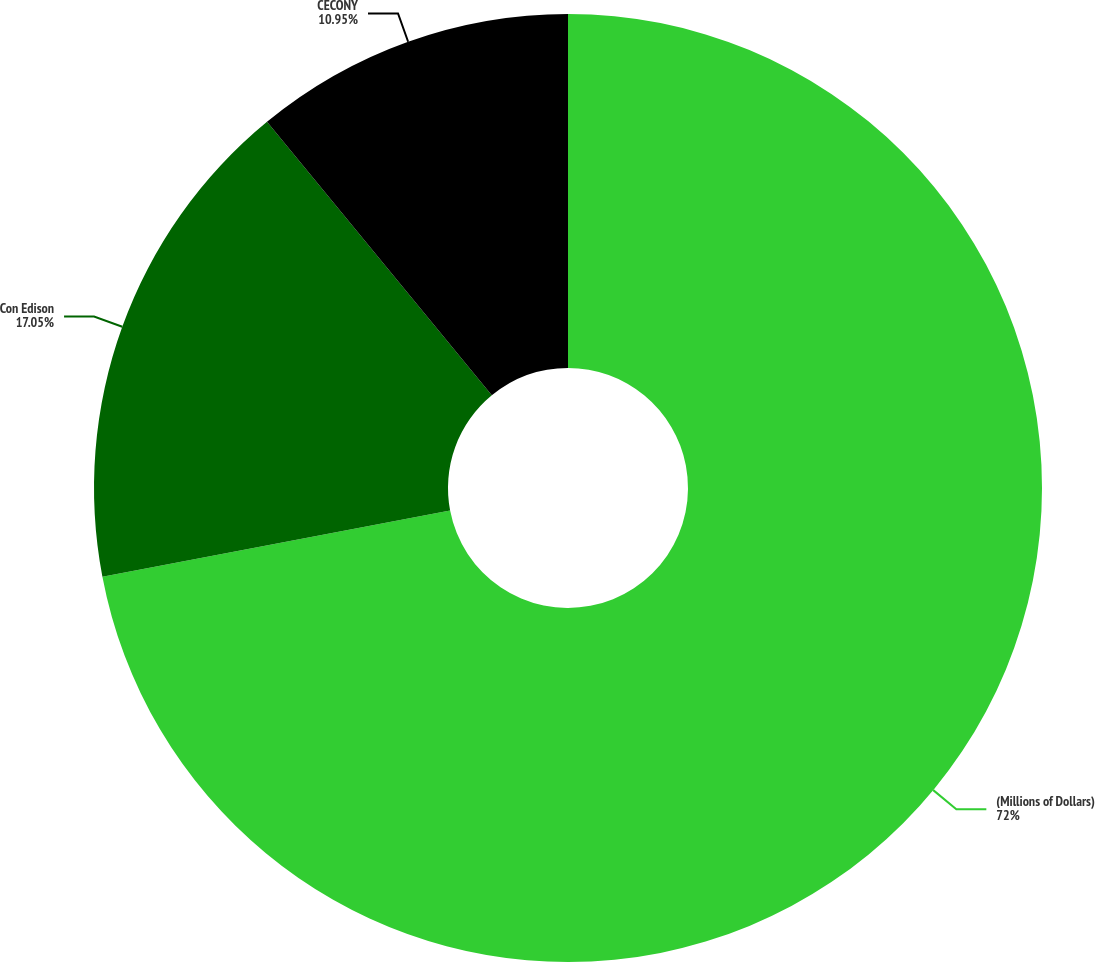Convert chart. <chart><loc_0><loc_0><loc_500><loc_500><pie_chart><fcel>(Millions of Dollars)<fcel>Con Edison<fcel>CECONY<nl><fcel>72.0%<fcel>17.05%<fcel>10.95%<nl></chart> 